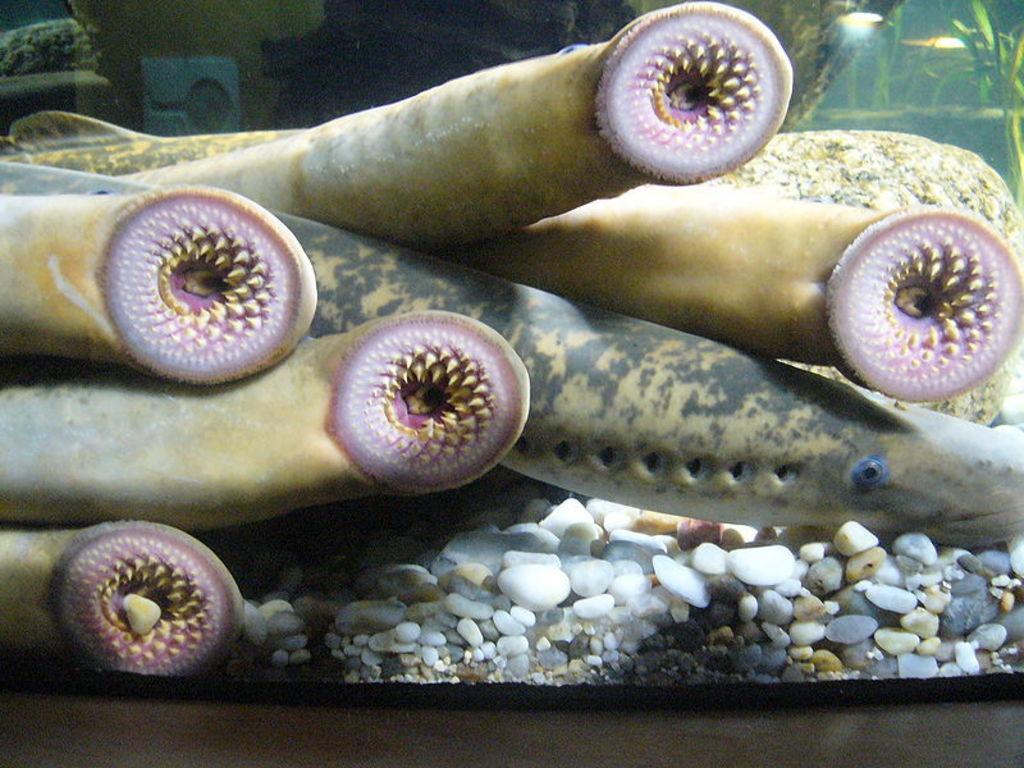Please provide a concise description of this image. In this image we can see an aquarium. In the center there is a fish and some water animals in the water. At the bottom there are stones. 